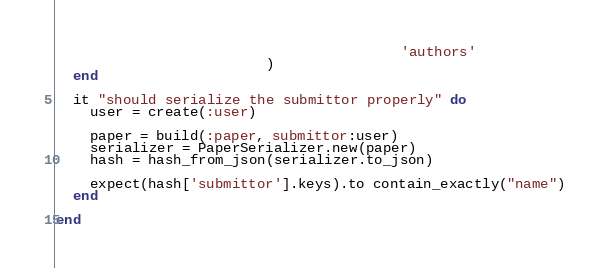<code> <loc_0><loc_0><loc_500><loc_500><_Ruby_>                                         'authors'
                         )
  end

  it "should serialize the submittor properly" do
    user = create(:user)

    paper = build(:paper, submittor:user)
    serializer = PaperSerializer.new(paper)
    hash = hash_from_json(serializer.to_json)

    expect(hash['submittor'].keys).to contain_exactly("name")
  end

end
</code> 